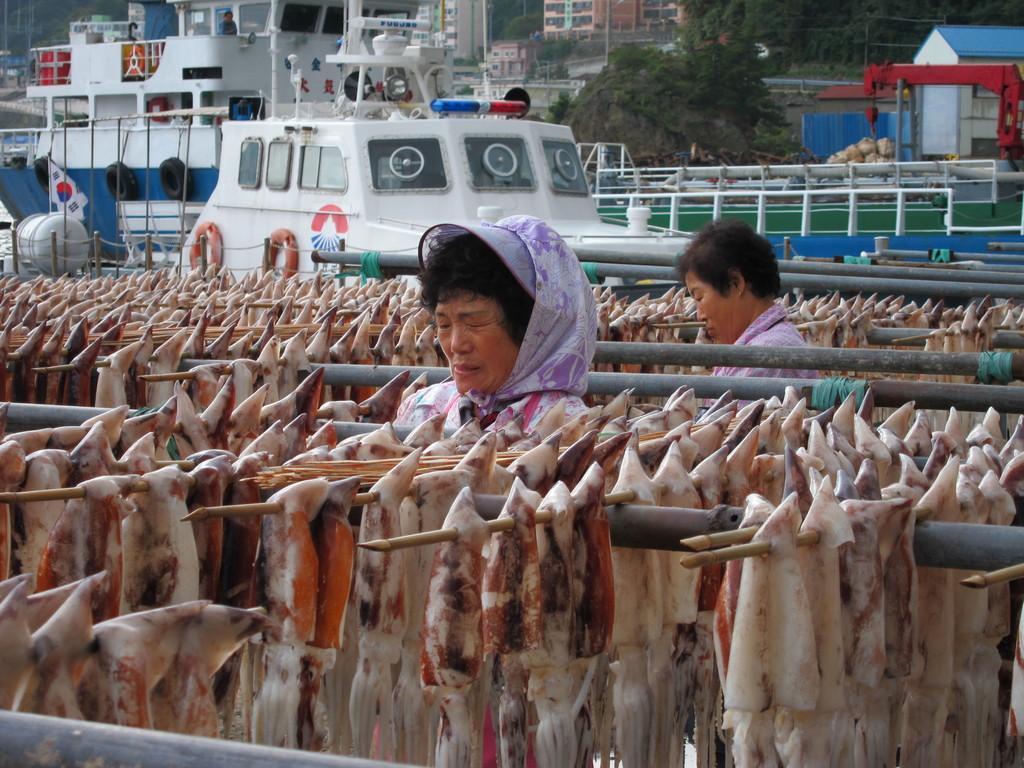In one or two sentences, can you explain what this image depicts? In this picture I can see the meat on the sticks and I see 2 women. In the middle of this picture I see few boats. In the background I can see the buildings and the trees. 